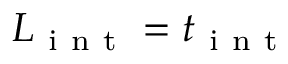<formula> <loc_0><loc_0><loc_500><loc_500>L _ { i n t } = t _ { i n t }</formula> 